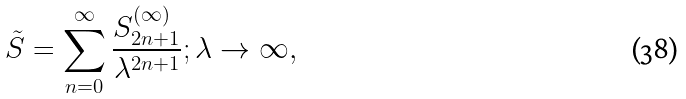<formula> <loc_0><loc_0><loc_500><loc_500>\tilde { S } = \sum _ { n = 0 } ^ { \infty } \frac { S _ { 2 n + 1 } ^ { ( \infty ) } } { \lambda ^ { 2 n + 1 } } ; \lambda \rightarrow \infty ,</formula> 